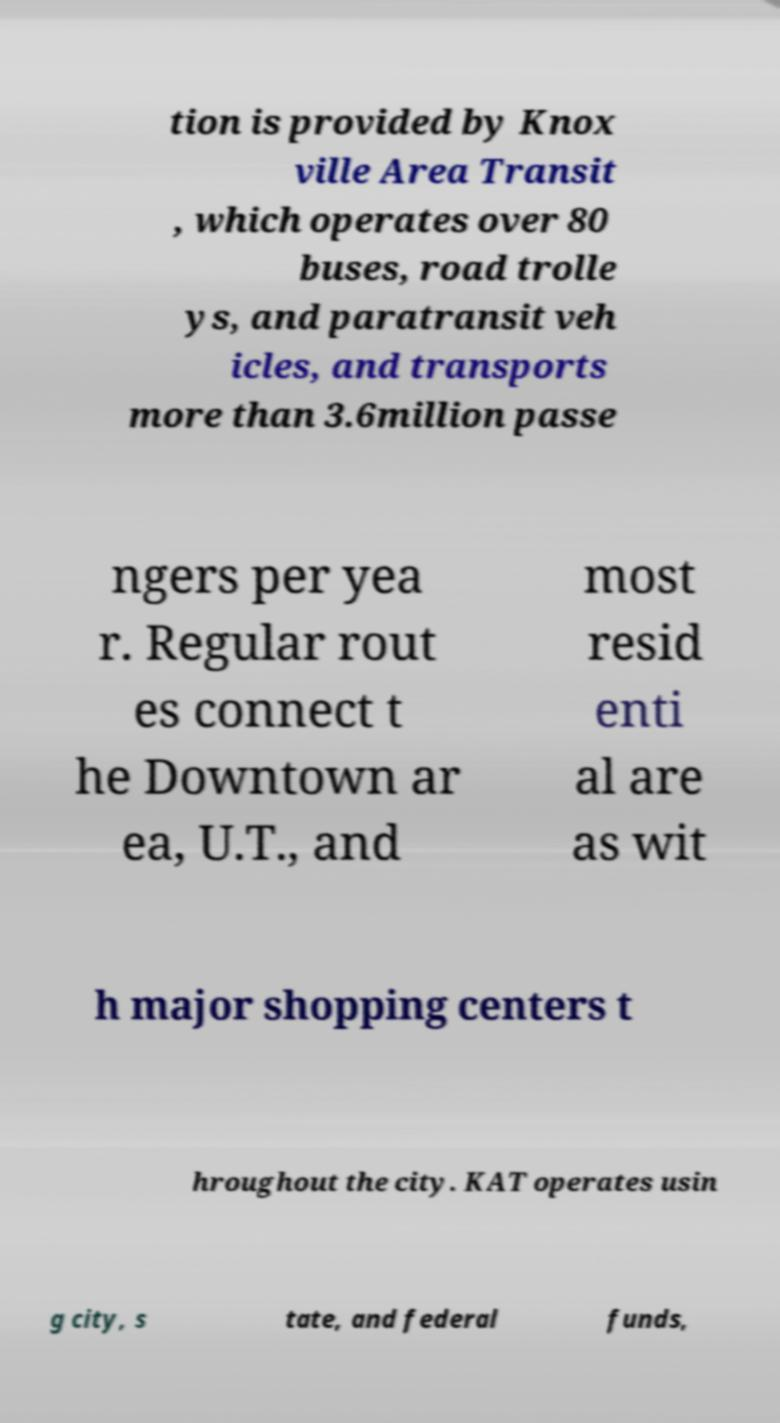Please read and relay the text visible in this image. What does it say? tion is provided by Knox ville Area Transit , which operates over 80 buses, road trolle ys, and paratransit veh icles, and transports more than 3.6million passe ngers per yea r. Regular rout es connect t he Downtown ar ea, U.T., and most resid enti al are as wit h major shopping centers t hroughout the city. KAT operates usin g city, s tate, and federal funds, 